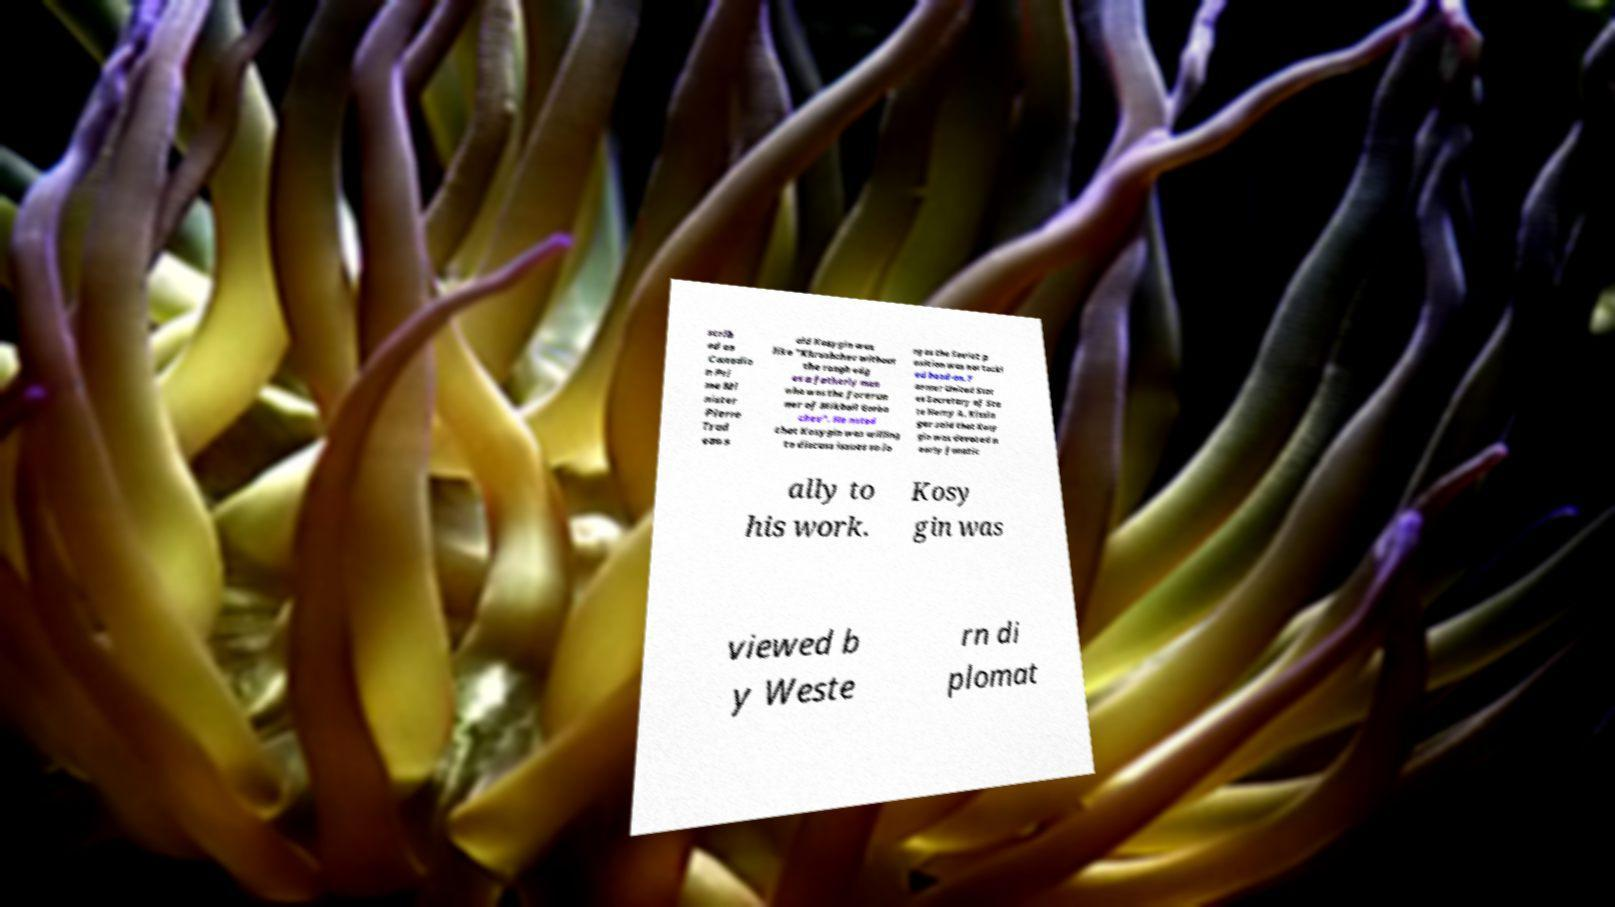Please read and relay the text visible in this image. What does it say? scrib ed as Canadia n Pri me Mi nister Pierre Trud eau s aid Kosygin was like "Khrushchev without the rough edg es a fatherly man who was the forerun ner of Mikhail Gorba chev". He noted that Kosygin was willing to discuss issues so lo ng as the Soviet p osition was not tackl ed head-on. F ormer United Stat es Secretary of Sta te Henry A. Kissin ger said that Kosy gin was devoted n early fanatic ally to his work. Kosy gin was viewed b y Weste rn di plomat 